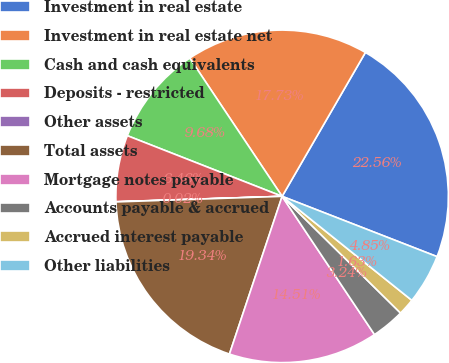Convert chart. <chart><loc_0><loc_0><loc_500><loc_500><pie_chart><fcel>Investment in real estate<fcel>Investment in real estate net<fcel>Cash and cash equivalents<fcel>Deposits - restricted<fcel>Other assets<fcel>Total assets<fcel>Mortgage notes payable<fcel>Accounts payable & accrued<fcel>Accrued interest payable<fcel>Other liabilities<nl><fcel>22.56%<fcel>17.73%<fcel>9.68%<fcel>6.46%<fcel>0.02%<fcel>19.34%<fcel>14.51%<fcel>3.24%<fcel>1.63%<fcel>4.85%<nl></chart> 